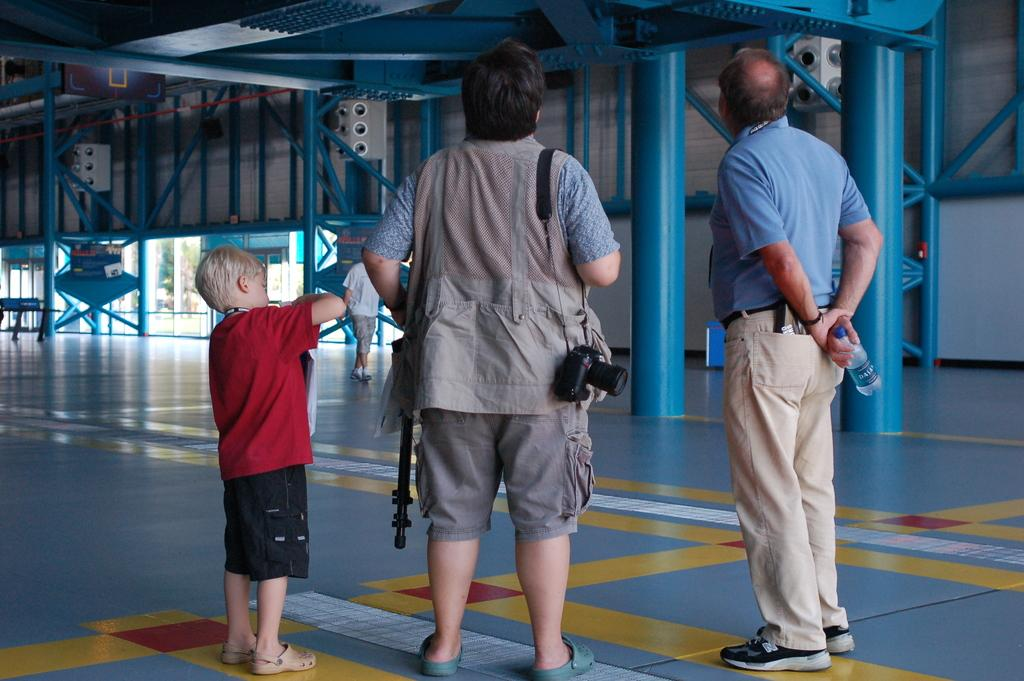How many people are present in the image? There are two people, a woman and a man, present in the image. What are the woman and the man doing in the image? The man is standing, and both the woman and the man have a camera. What can be seen in the background of the image? There are blue color poles and a door at the right side backdrop of the image. What type of art can be seen hanging on the wall in the image? There is no art hanging on the wall in the image; it only features blue color poles and a door in the background. Is there a jail visible in the image? No, there is no jail present in the image. 